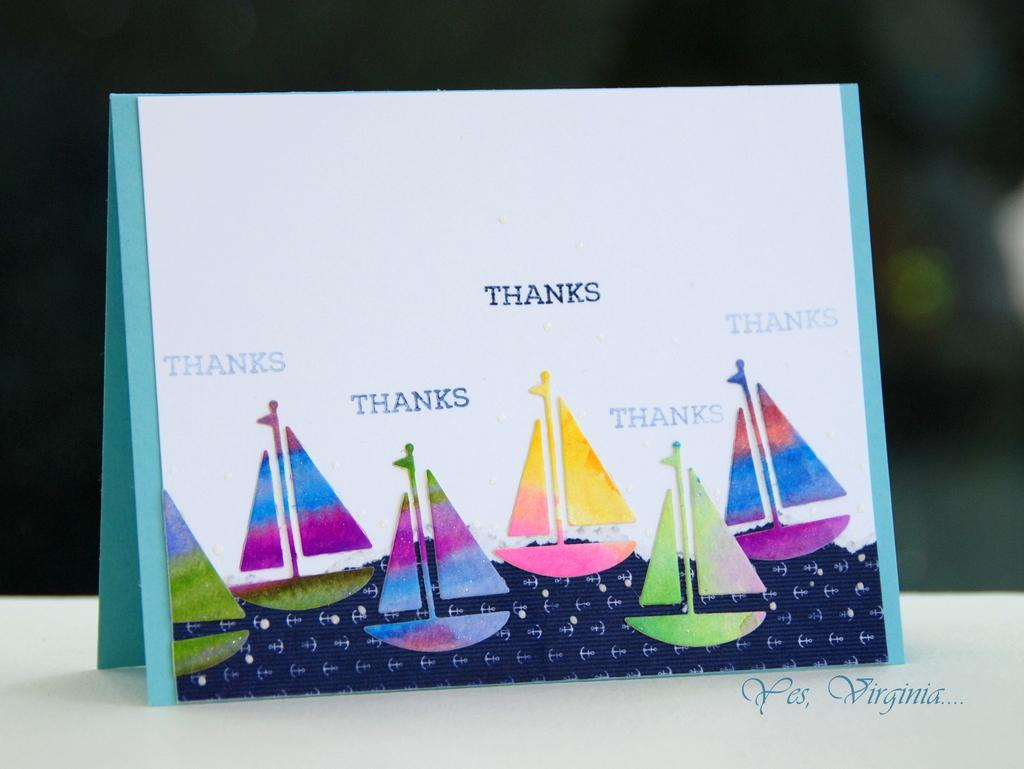What type of objects are featured in the image? The image consists of cards. What message is written on the card? The card has "thanks" written on it. What images are present on the card? There are pictures of boats on the card. Where is the kitten hiding in the image? There is no kitten present in the image. What type of glue is used to attach the card to the mailbox? There is no mailbox or glue present in the image; it only features cards with a message and images. 